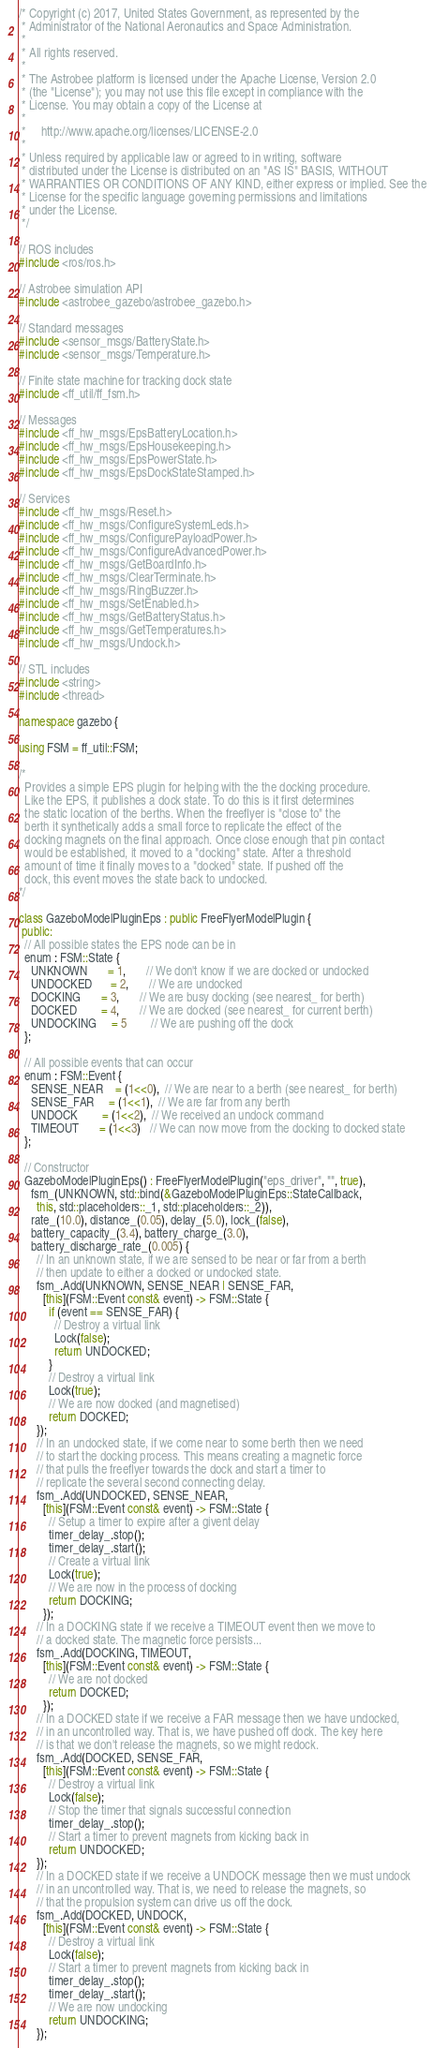Convert code to text. <code><loc_0><loc_0><loc_500><loc_500><_C++_>/* Copyright (c) 2017, United States Government, as represented by the
 * Administrator of the National Aeronautics and Space Administration.
 *
 * All rights reserved.
 *
 * The Astrobee platform is licensed under the Apache License, Version 2.0
 * (the "License"); you may not use this file except in compliance with the
 * License. You may obtain a copy of the License at
 *
 *     http://www.apache.org/licenses/LICENSE-2.0
 *
 * Unless required by applicable law or agreed to in writing, software
 * distributed under the License is distributed on an "AS IS" BASIS, WITHOUT
 * WARRANTIES OR CONDITIONS OF ANY KIND, either express or implied. See the
 * License for the specific language governing permissions and limitations
 * under the License.
 */

// ROS includes
#include <ros/ros.h>

// Astrobee simulation API
#include <astrobee_gazebo/astrobee_gazebo.h>

// Standard messages
#include <sensor_msgs/BatteryState.h>
#include <sensor_msgs/Temperature.h>

// Finite state machine for tracking dock state
#include <ff_util/ff_fsm.h>

// Messages
#include <ff_hw_msgs/EpsBatteryLocation.h>
#include <ff_hw_msgs/EpsHousekeeping.h>
#include <ff_hw_msgs/EpsPowerState.h>
#include <ff_hw_msgs/EpsDockStateStamped.h>

// Services
#include <ff_hw_msgs/Reset.h>
#include <ff_hw_msgs/ConfigureSystemLeds.h>
#include <ff_hw_msgs/ConfigurePayloadPower.h>
#include <ff_hw_msgs/ConfigureAdvancedPower.h>
#include <ff_hw_msgs/GetBoardInfo.h>
#include <ff_hw_msgs/ClearTerminate.h>
#include <ff_hw_msgs/RingBuzzer.h>
#include <ff_hw_msgs/SetEnabled.h>
#include <ff_hw_msgs/GetBatteryStatus.h>
#include <ff_hw_msgs/GetTemperatures.h>
#include <ff_hw_msgs/Undock.h>

// STL includes
#include <string>
#include <thread>

namespace gazebo {

using FSM = ff_util::FSM;

/*
  Provides a simple EPS plugin for helping with the the docking procedure.
  Like the EPS, it publishes a dock state. To do this is it first determines
  the static location of the berths. When the freeflyer is "close to" the
  berth it synthetically adds a small force to replicate the effect of the
  docking magnets on the final approach. Once close enough that pin contact
  would be established, it moved to a "docking" state. After a threshold
  amount of time it finally moves to a "docked" state. If pushed off the
  dock, this event moves the state back to undocked.
*/

class GazeboModelPluginEps : public FreeFlyerModelPlugin {
 public:
  // All possible states the EPS node can be in
  enum : FSM::State {
    UNKNOWN       = 1,       // We don't know if we are docked or undocked
    UNDOCKED      = 2,       // We are undocked
    DOCKING       = 3,       // We are busy docking (see nearest_ for berth)
    DOCKED        = 4,       // We are docked (see nearest_ for current berth)
    UNDOCKING     = 5        // We are pushing off the dock
  };

  // All possible events that can occur
  enum : FSM::Event {
    SENSE_NEAR    = (1<<0),  // We are near to a berth (see nearest_ for berth)
    SENSE_FAR     = (1<<1),  // We are far from any berth
    UNDOCK        = (1<<2),  // We received an undock command
    TIMEOUT       = (1<<3)   // We can now move from the docking to docked state
  };

  // Constructor
  GazeboModelPluginEps() : FreeFlyerModelPlugin("eps_driver", "", true),
    fsm_(UNKNOWN, std::bind(&GazeboModelPluginEps::StateCallback,
      this, std::placeholders::_1, std::placeholders::_2)),
    rate_(10.0), distance_(0.05), delay_(5.0), lock_(false),
    battery_capacity_(3.4), battery_charge_(3.0),
    battery_discharge_rate_(0.005) {
      // In an unknown state, if we are sensed to be near or far from a berth
      // then update to either a docked or undocked state.
      fsm_.Add(UNKNOWN, SENSE_NEAR | SENSE_FAR,
        [this](FSM::Event const& event) -> FSM::State {
          if (event == SENSE_FAR) {
            // Destroy a virtual link
            Lock(false);
            return UNDOCKED;
          }
          // Destroy a virtual link
          Lock(true);
          // We are now docked (and magnetised)
          return DOCKED;
      });
      // In an undocked state, if we come near to some berth then we need
      // to start the docking process. This means creating a magnetic force
      // that pulls the freeflyer towards the dock and start a timer to
      // replicate the several second connecting delay.
      fsm_.Add(UNDOCKED, SENSE_NEAR,
        [this](FSM::Event const& event) -> FSM::State {
          // Setup a timer to expire after a givent delay
          timer_delay_.stop();
          timer_delay_.start();
          // Create a virtual link
          Lock(true);
          // We are now in the process of docking
          return DOCKING;
        });
      // In a DOCKING state if we receive a TIMEOUT event then we move to
      // a docked state. The magnetic force persists...
      fsm_.Add(DOCKING, TIMEOUT,
        [this](FSM::Event const& event) -> FSM::State {
          // We are not docked
          return DOCKED;
        });
      // In a DOCKED state if we receive a FAR message then we have undocked,
      // in an uncontrolled way. That is, we have pushed off dock. The key here
      // is that we don't release the magnets, so we might redock.
      fsm_.Add(DOCKED, SENSE_FAR,
        [this](FSM::Event const& event) -> FSM::State {
          // Destroy a virtual link
          Lock(false);
          // Stop the timer that signals successful connection
          timer_delay_.stop();
          // Start a timer to prevent magnets from kicking back in
          return UNDOCKED;
      });
      // In a DOCKED state if we receive a UNDOCK message then we must undock
      // in an uncontrolled way. That is, we need to release the magnets, so
      // that the propulsion system can drive us off the dock.
      fsm_.Add(DOCKED, UNDOCK,
        [this](FSM::Event const& event) -> FSM::State {
          // Destroy a virtual link
          Lock(false);
          // Start a timer to prevent magnets from kicking back in
          timer_delay_.stop();
          timer_delay_.start();
          // We are now undocking
          return UNDOCKING;
      });</code> 